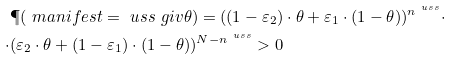Convert formula to latex. <formula><loc_0><loc_0><loc_500><loc_500>& \P ( \ m a n i f e s t = \ u s s \ g i v \theta ) = ( ( 1 - \varepsilon _ { 2 } ) \cdot \theta + \varepsilon _ { 1 } \cdot ( 1 - \theta ) ) ^ { n ^ { \ u s s } } \cdot \\ \cdot & ( \varepsilon _ { 2 } \cdot \theta + ( 1 - \varepsilon _ { 1 } ) \cdot ( 1 - \theta ) ) ^ { N - n ^ { \ u s s } } > 0 \\</formula> 